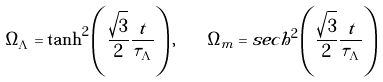Convert formula to latex. <formula><loc_0><loc_0><loc_500><loc_500>\Omega _ { \Lambda } = \tanh ^ { 2 } \left ( \frac { \sqrt { 3 } } { 2 } \frac { t } { \tau _ { \Lambda } } \right ) , \quad \Omega _ { m } = s e c h ^ { 2 } \left ( \frac { \sqrt { 3 } } { 2 } \frac { t } { \tau _ { \Lambda } } \right )</formula> 